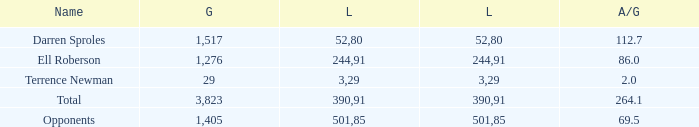When the player gained below 1,405 yards and lost over 390 yards, what's the sum of the long yards? None. 